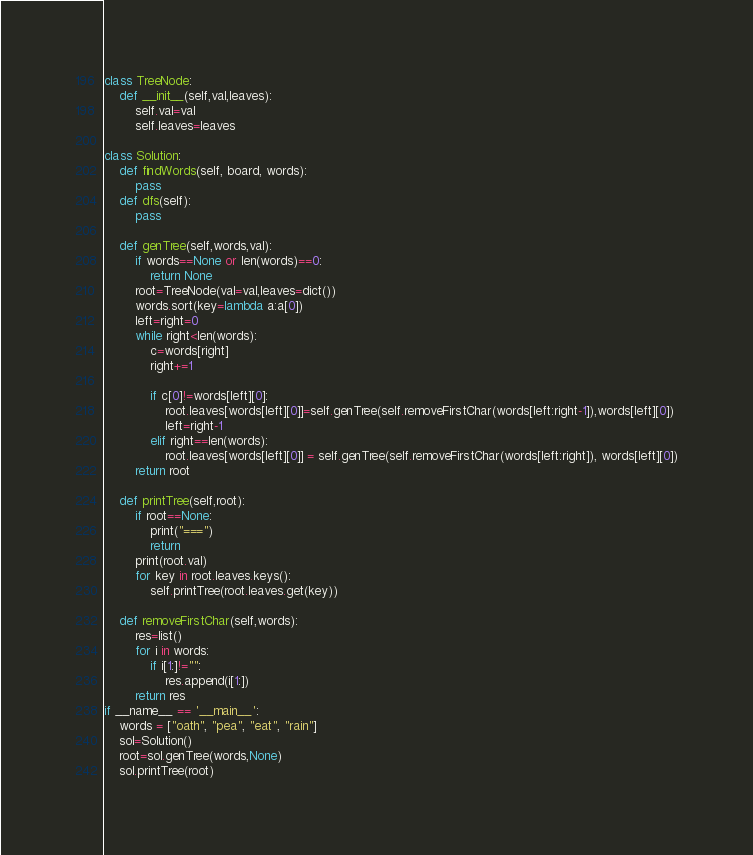<code> <loc_0><loc_0><loc_500><loc_500><_Python_>class TreeNode:
    def __init__(self,val,leaves):
        self.val=val
        self.leaves=leaves

class Solution:
    def findWords(self, board, words):
        pass
    def dfs(self):
        pass

    def genTree(self,words,val):
        if words==None or len(words)==0:
            return None
        root=TreeNode(val=val,leaves=dict())
        words.sort(key=lambda a:a[0])
        left=right=0
        while right<len(words):
            c=words[right]
            right+=1

            if c[0]!=words[left][0]:
                root.leaves[words[left][0]]=self.genTree(self.removeFirstChar(words[left:right-1]),words[left][0])
                left=right-1
            elif right==len(words):
                root.leaves[words[left][0]] = self.genTree(self.removeFirstChar(words[left:right]), words[left][0])
        return root

    def printTree(self,root):
        if root==None:
            print("===")
            return
        print(root.val)
        for key in root.leaves.keys():
            self.printTree(root.leaves.get(key))

    def removeFirstChar(self,words):
        res=list()
        for i in words:
            if i[1:]!="":
                res.append(i[1:])
        return res
if __name__ == '__main__':
    words = ["oath", "pea", "eat", "rain"]
    sol=Solution()
    root=sol.genTree(words,None)
    sol.printTree(root)

</code> 